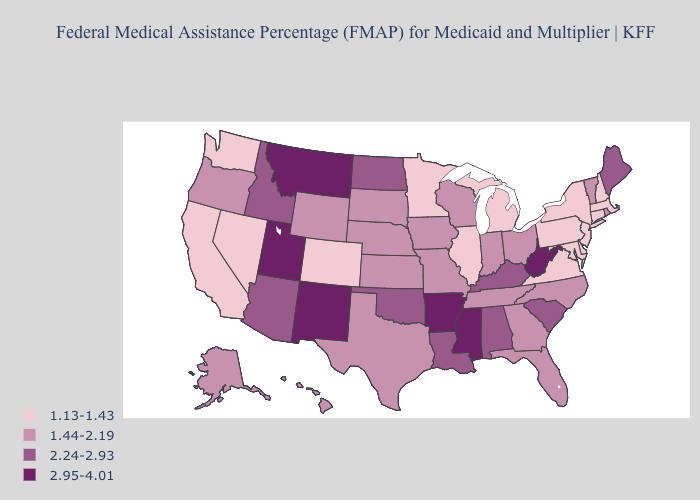Does Rhode Island have the lowest value in the Northeast?
Be succinct. No. Name the states that have a value in the range 2.95-4.01?
Write a very short answer. Arkansas, Mississippi, Montana, New Mexico, Utah, West Virginia. Which states hav the highest value in the Northeast?
Short answer required. Maine. What is the value of Montana?
Concise answer only. 2.95-4.01. Among the states that border Maryland , does West Virginia have the lowest value?
Write a very short answer. No. What is the value of North Carolina?
Keep it brief. 1.44-2.19. Name the states that have a value in the range 1.13-1.43?
Short answer required. California, Colorado, Connecticut, Delaware, Illinois, Maryland, Massachusetts, Michigan, Minnesota, Nevada, New Hampshire, New Jersey, New York, Pennsylvania, Virginia, Washington. Which states have the highest value in the USA?
Quick response, please. Arkansas, Mississippi, Montana, New Mexico, Utah, West Virginia. Among the states that border Tennessee , which have the highest value?
Write a very short answer. Arkansas, Mississippi. Name the states that have a value in the range 1.13-1.43?
Give a very brief answer. California, Colorado, Connecticut, Delaware, Illinois, Maryland, Massachusetts, Michigan, Minnesota, Nevada, New Hampshire, New Jersey, New York, Pennsylvania, Virginia, Washington. Does Maryland have the lowest value in the USA?
Quick response, please. Yes. Which states hav the highest value in the Northeast?
Answer briefly. Maine. Is the legend a continuous bar?
Answer briefly. No. What is the lowest value in states that border Vermont?
Give a very brief answer. 1.13-1.43. Does the map have missing data?
Be succinct. No. 